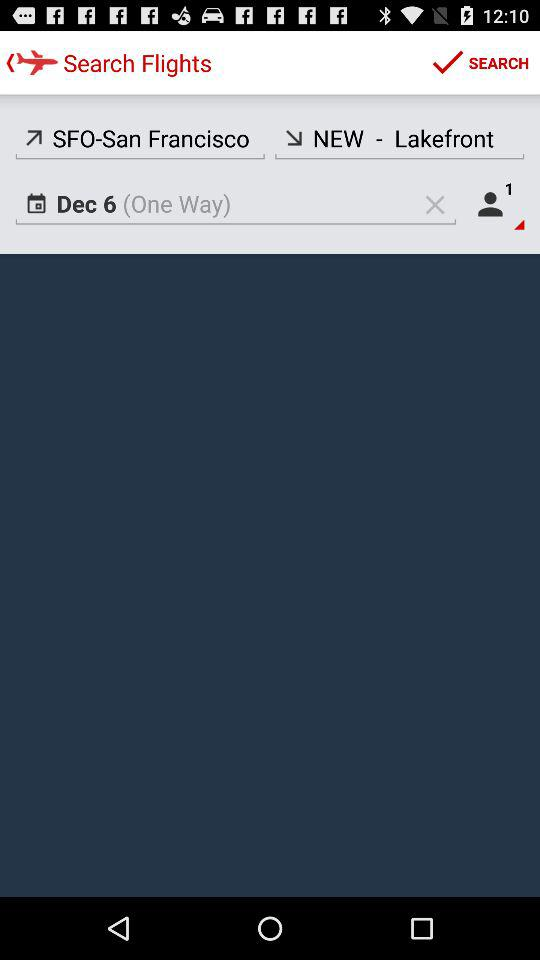What's the number of passengers? The number of passengers is 1. 